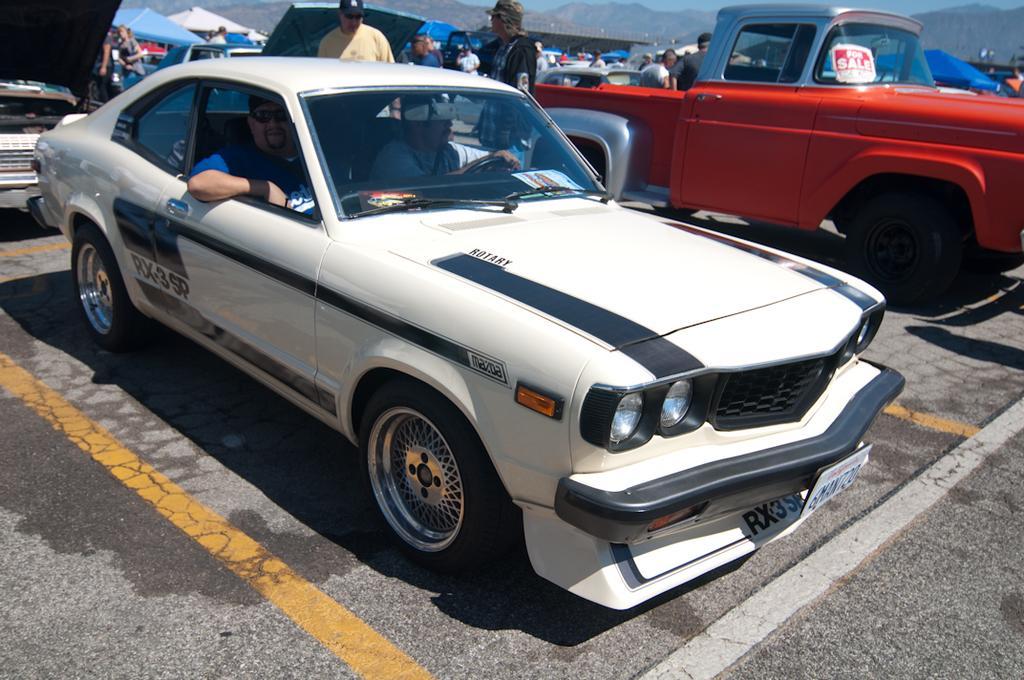Please provide a concise description of this image. In this image we can see cars, tents and people. In the background we can see mountains and sky. We can also see the road.  